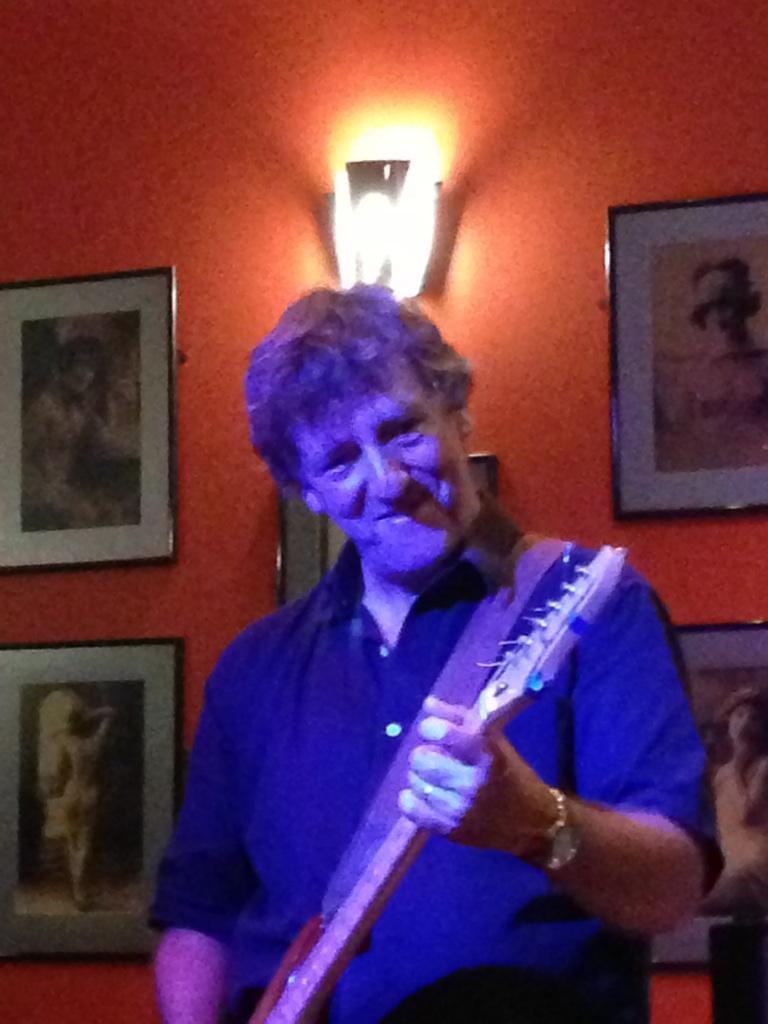Please provide a concise description of this image. In this image there is one man who is standing and he is holding a guitar, on the background there is a wall on that wall there are some photo frames and light is there. 